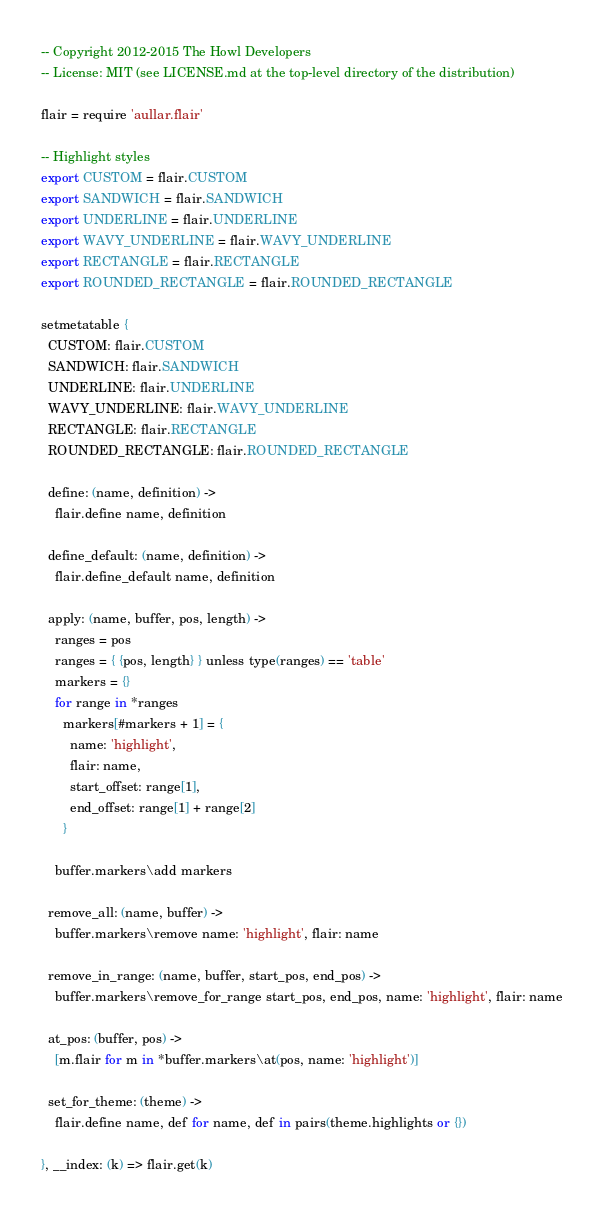Convert code to text. <code><loc_0><loc_0><loc_500><loc_500><_MoonScript_>-- Copyright 2012-2015 The Howl Developers
-- License: MIT (see LICENSE.md at the top-level directory of the distribution)

flair = require 'aullar.flair'

-- Highlight styles
export CUSTOM = flair.CUSTOM
export SANDWICH = flair.SANDWICH
export UNDERLINE = flair.UNDERLINE
export WAVY_UNDERLINE = flair.WAVY_UNDERLINE
export RECTANGLE = flair.RECTANGLE
export ROUNDED_RECTANGLE = flair.ROUNDED_RECTANGLE

setmetatable {
  CUSTOM: flair.CUSTOM
  SANDWICH: flair.SANDWICH
  UNDERLINE: flair.UNDERLINE
  WAVY_UNDERLINE: flair.WAVY_UNDERLINE
  RECTANGLE: flair.RECTANGLE
  ROUNDED_RECTANGLE: flair.ROUNDED_RECTANGLE

  define: (name, definition) ->
    flair.define name, definition

  define_default: (name, definition) ->
    flair.define_default name, definition

  apply: (name, buffer, pos, length) ->
    ranges = pos
    ranges = { {pos, length} } unless type(ranges) == 'table'
    markers = {}
    for range in *ranges
      markers[#markers + 1] = {
        name: 'highlight',
        flair: name,
        start_offset: range[1],
        end_offset: range[1] + range[2]
      }

    buffer.markers\add markers

  remove_all: (name, buffer) ->
    buffer.markers\remove name: 'highlight', flair: name

  remove_in_range: (name, buffer, start_pos, end_pos) ->
    buffer.markers\remove_for_range start_pos, end_pos, name: 'highlight', flair: name

  at_pos: (buffer, pos) ->
    [m.flair for m in *buffer.markers\at(pos, name: 'highlight')]

  set_for_theme: (theme) ->
    flair.define name, def for name, def in pairs(theme.highlights or {})

}, __index: (k) => flair.get(k)
</code> 